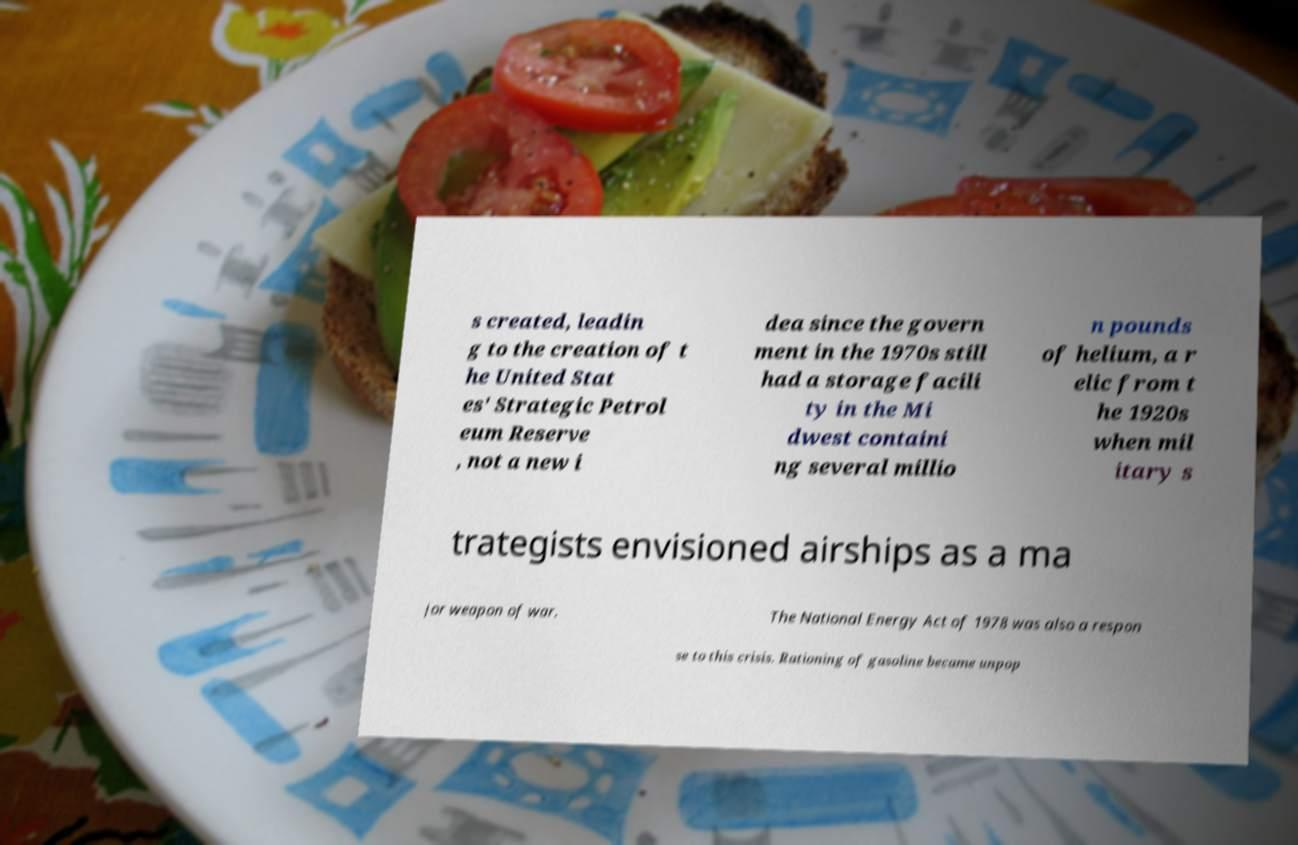Could you assist in decoding the text presented in this image and type it out clearly? s created, leadin g to the creation of t he United Stat es' Strategic Petrol eum Reserve , not a new i dea since the govern ment in the 1970s still had a storage facili ty in the Mi dwest containi ng several millio n pounds of helium, a r elic from t he 1920s when mil itary s trategists envisioned airships as a ma jor weapon of war. The National Energy Act of 1978 was also a respon se to this crisis. Rationing of gasoline became unpop 